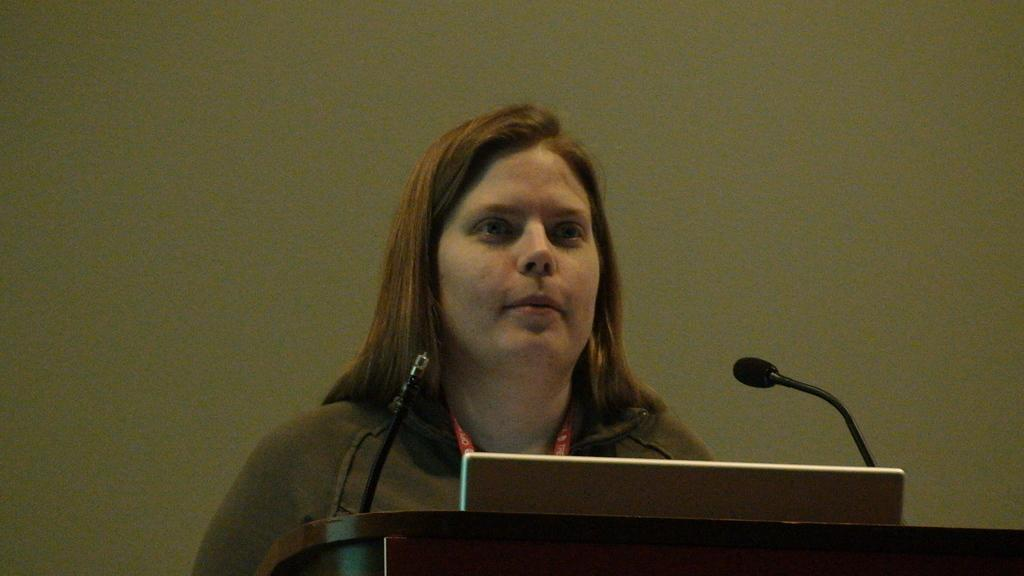What can be seen in the image? There is a person in the image. What is the person wearing? The person is wearing a brown shirt. What objects are in front of the person? There are two microphones and a laptop in front of the person. What color is the wall in the background? The wall in the background is green. What type of whip is the person using in the image? There is no whip present in the image. What meal is the person preparing with the microphones and laptop? The image does not depict a meal or any food preparation; it shows a person with microphones and a laptop. 